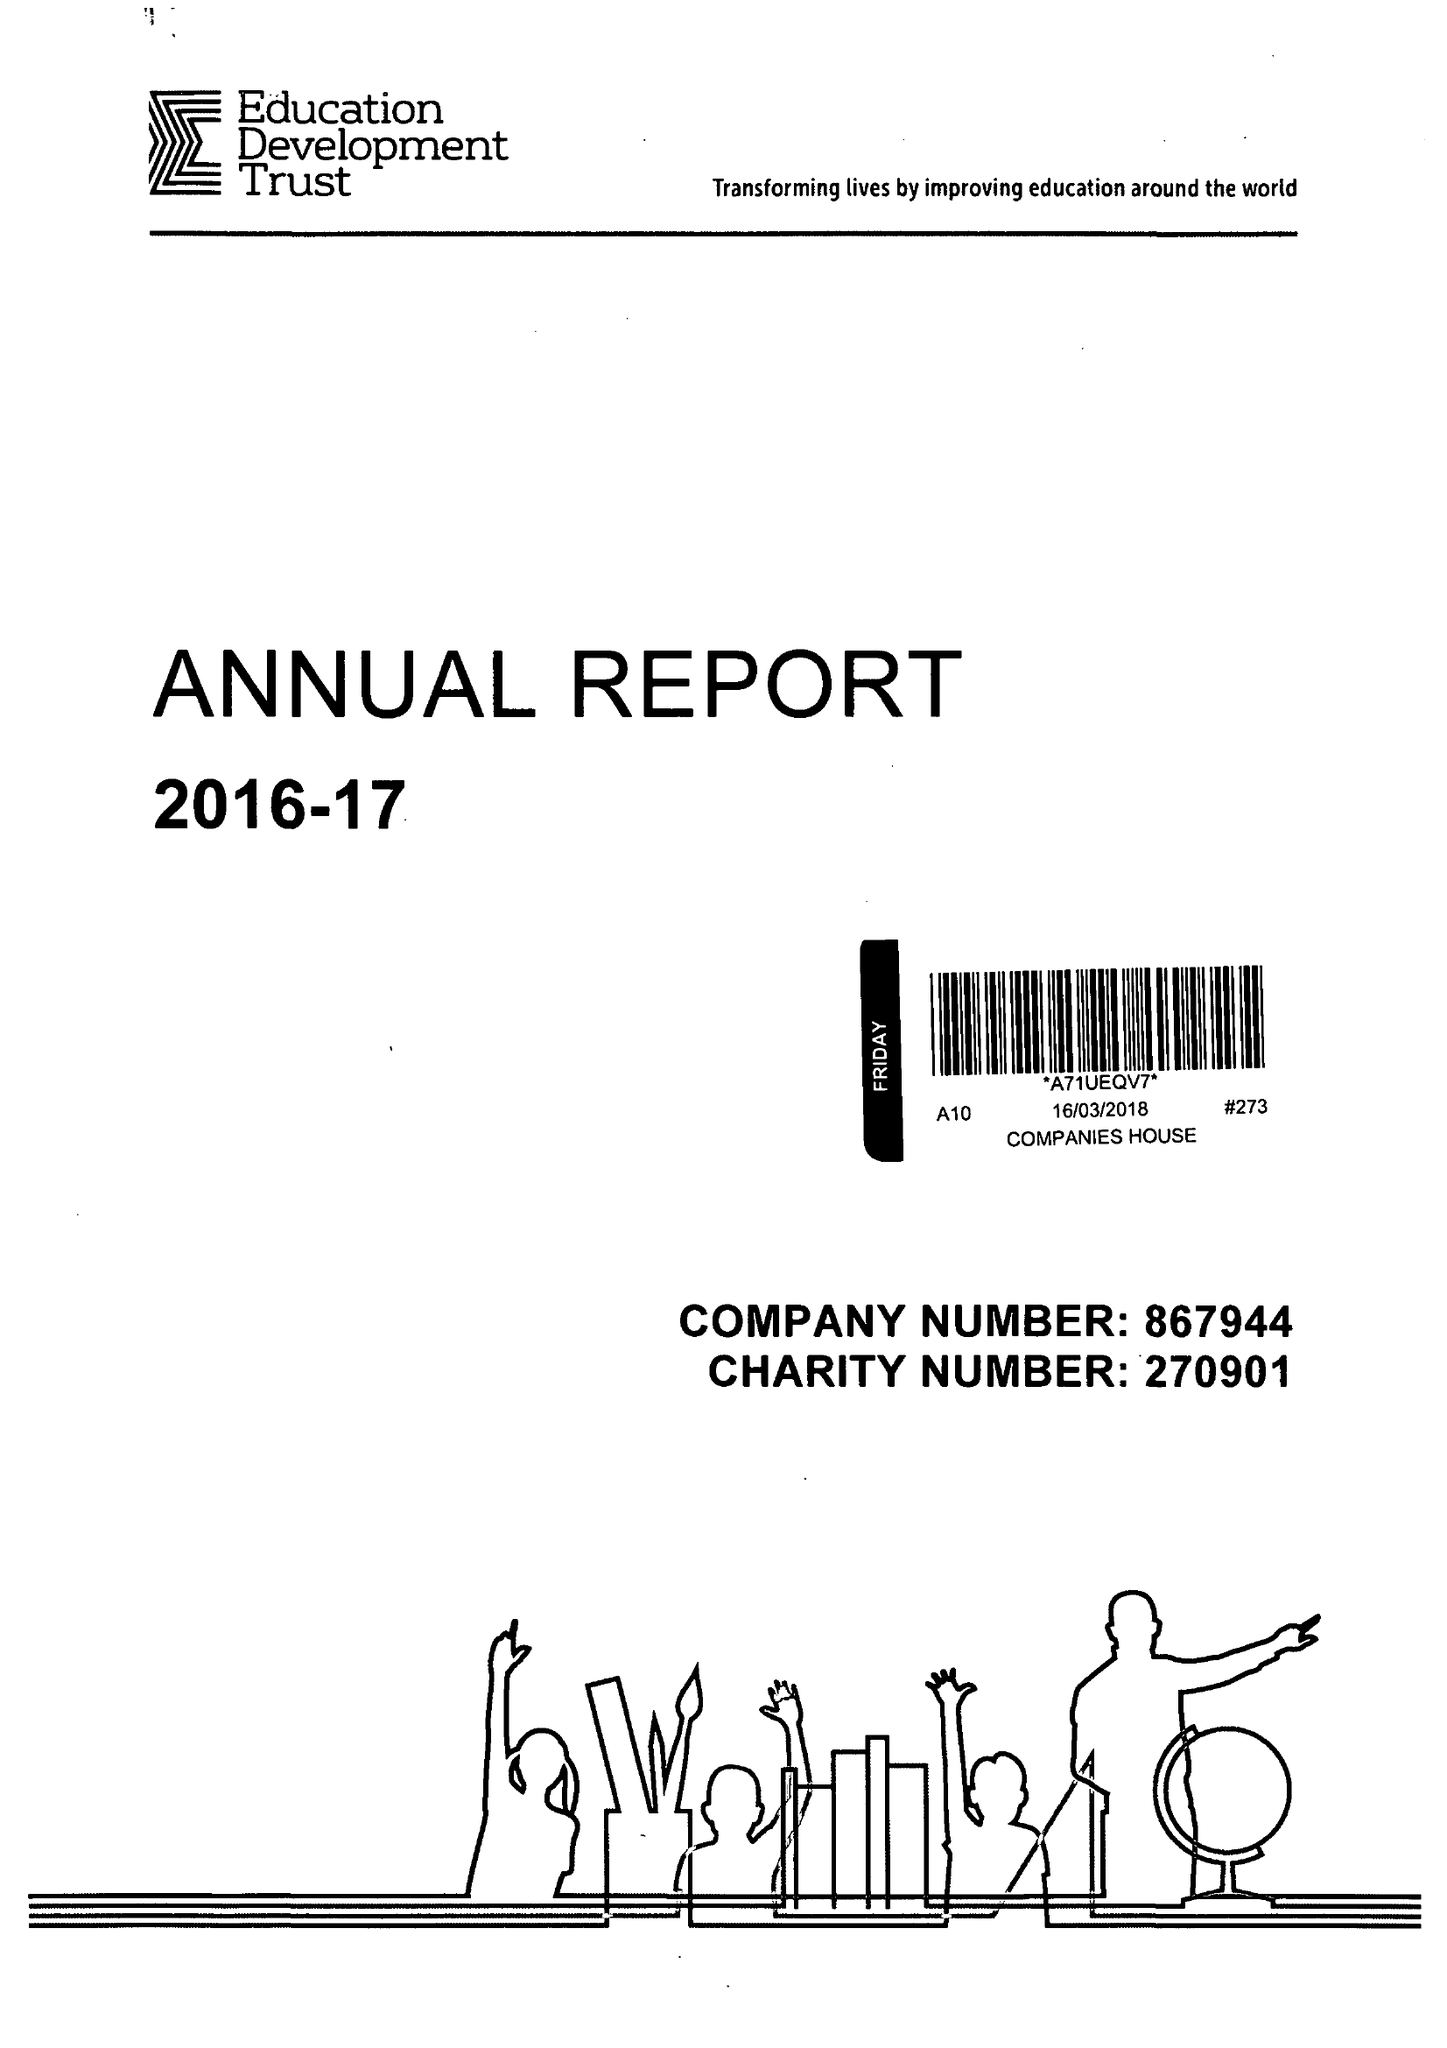What is the value for the address__street_line?
Answer the question using a single word or phrase. 16-18 DUKE STREET 